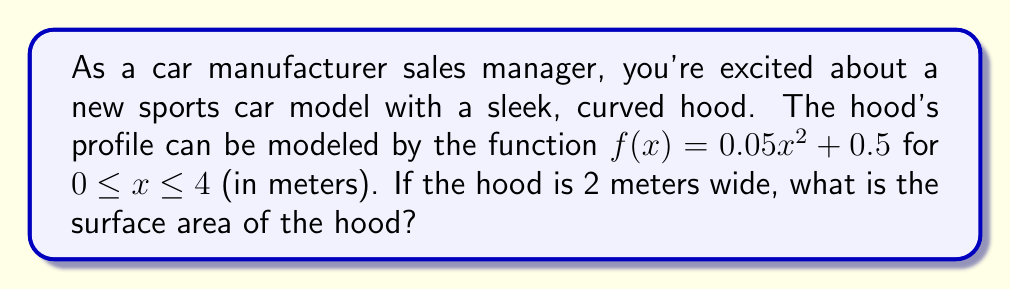Teach me how to tackle this problem. To calculate the surface area of the curved hood, we need to use the formula for the surface area of a surface of revolution:

$$ A = 2\pi \int_a^b f(x) \sqrt{1 + [f'(x)]^2} dx $$

Where $f(x)$ is the function describing the curve, and $[a,b]$ is the interval over which we're integrating.

Steps:
1) First, we need to find $f'(x)$:
   $f(x) = 0.05x^2 + 0.5$
   $f'(x) = 0.1x$

2) Now, let's set up the integral:
   $$ A = 2\pi \int_0^4 (0.05x^2 + 0.5) \sqrt{1 + (0.1x)^2} dx $$

3) This integral is complex, so we'll use numerical integration methods or a computer algebra system to evaluate it. The result is approximately 25.5415 square meters.

4) However, this result assumes the hood goes all the way around (like a full revolution). Since our hood is only 2 meters wide, we need to adjust our result.

5) The circumference of a full revolution would be $2\pi r$, where $r$ is the radius. In our case, $r = 2$ (half the width of the hood). So the full circumference would be $4\pi$ meters.

6) Our actual width is 2 meters, so we need to multiply our result by $\frac{2}{4\pi}$:

   $$ 25.5415 * \frac{2}{4\pi} \approx 4.0660 $$

Therefore, the surface area of the hood is approximately 4.0660 square meters.
Answer: The surface area of the hood is approximately 4.0660 square meters. 